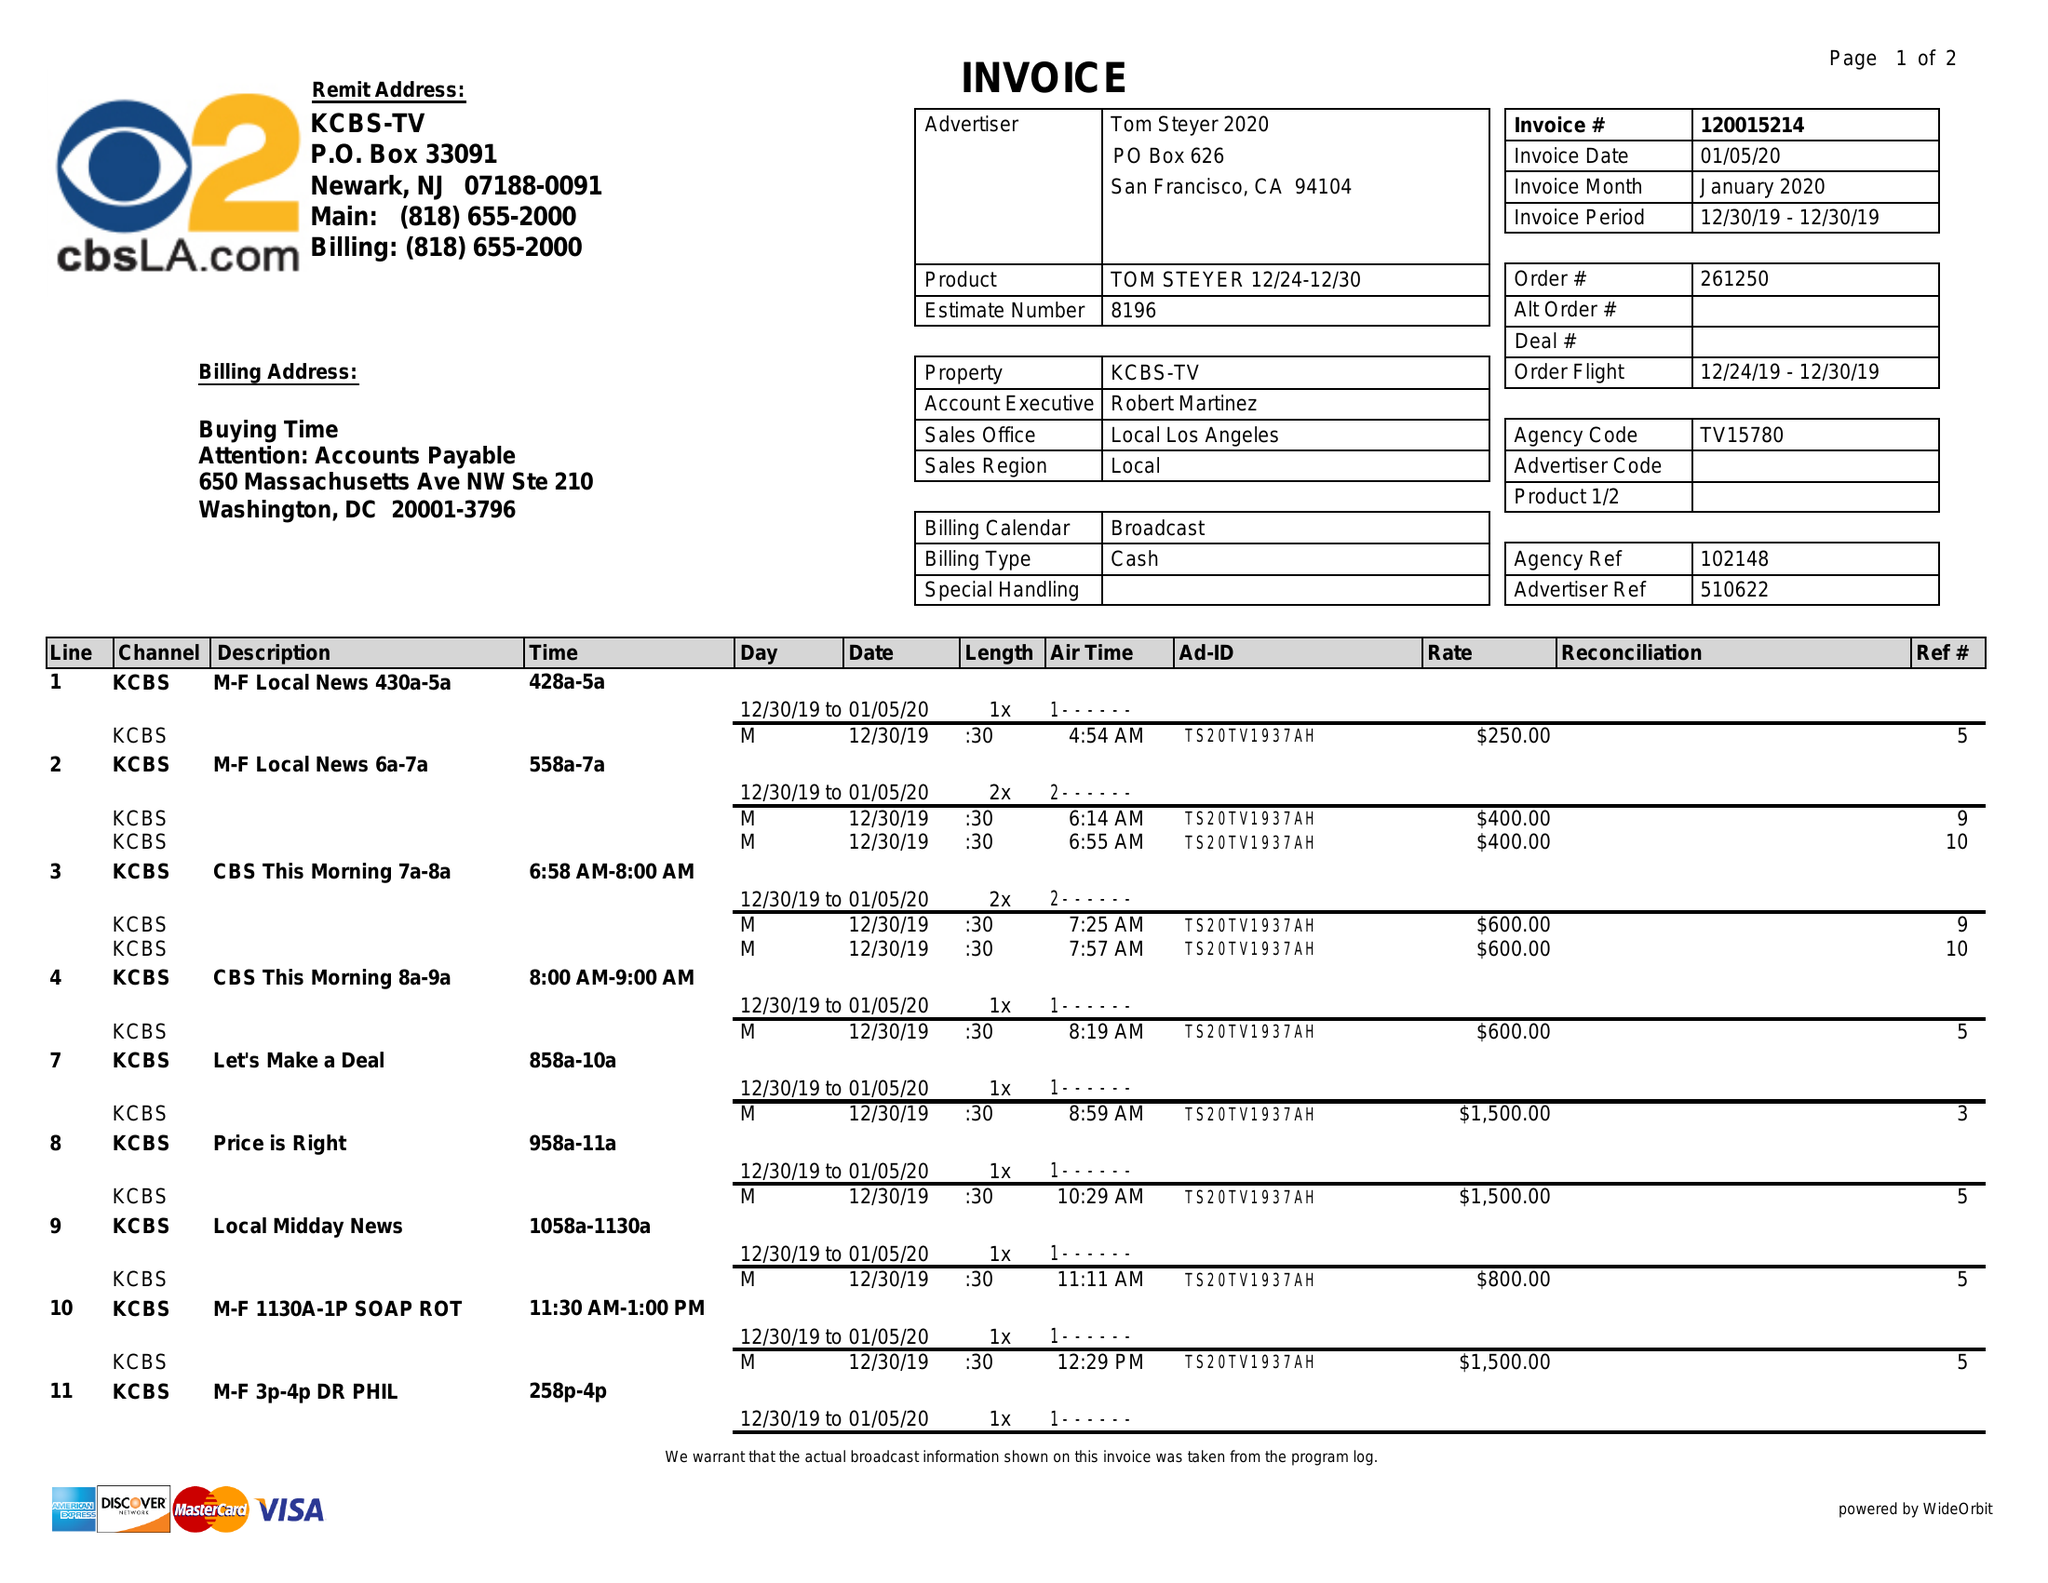What is the value for the advertiser?
Answer the question using a single word or phrase. TOM STEYER 2020 